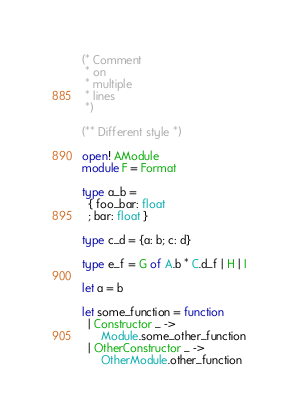Convert code to text. <code><loc_0><loc_0><loc_500><loc_500><_OCaml_>(* Comment
 * on
 * multiple
 * lines
 *)

(** Different style *)

open! AModule
module F = Format

type a_b =
  { foo_bar: float
  ; bar: float }

type c_d = {a: b; c: d}

type e_f = G of A.b * C.d_f | H | I

let a = b

let some_function = function
  | Constructor _ ->
      Module.some_other_function
  | OtherConstructor _ ->
      OtherModule.other_function
</code> 